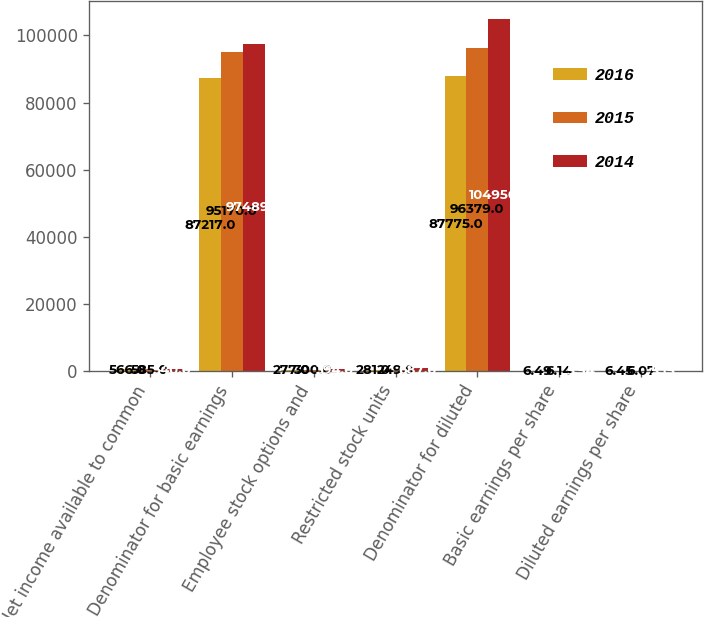Convert chart to OTSL. <chart><loc_0><loc_0><loc_500><loc_500><stacked_bar_chart><ecel><fcel>Net income available to common<fcel>Denominator for basic earnings<fcel>Employee stock options and<fcel>Restricted stock units<fcel>Denominator for diluted<fcel>Basic earnings per share<fcel>Diluted earnings per share<nl><fcel>2016<fcel>566<fcel>87217<fcel>277<fcel>281<fcel>87775<fcel>6.49<fcel>6.45<nl><fcel>2015<fcel>585<fcel>95170<fcel>300<fcel>249<fcel>96379<fcel>6.14<fcel>6.07<nl><fcel>2014<fcel>540<fcel>97489<fcel>394<fcel>687<fcel>104956<fcel>5.54<fcel>5.15<nl></chart> 